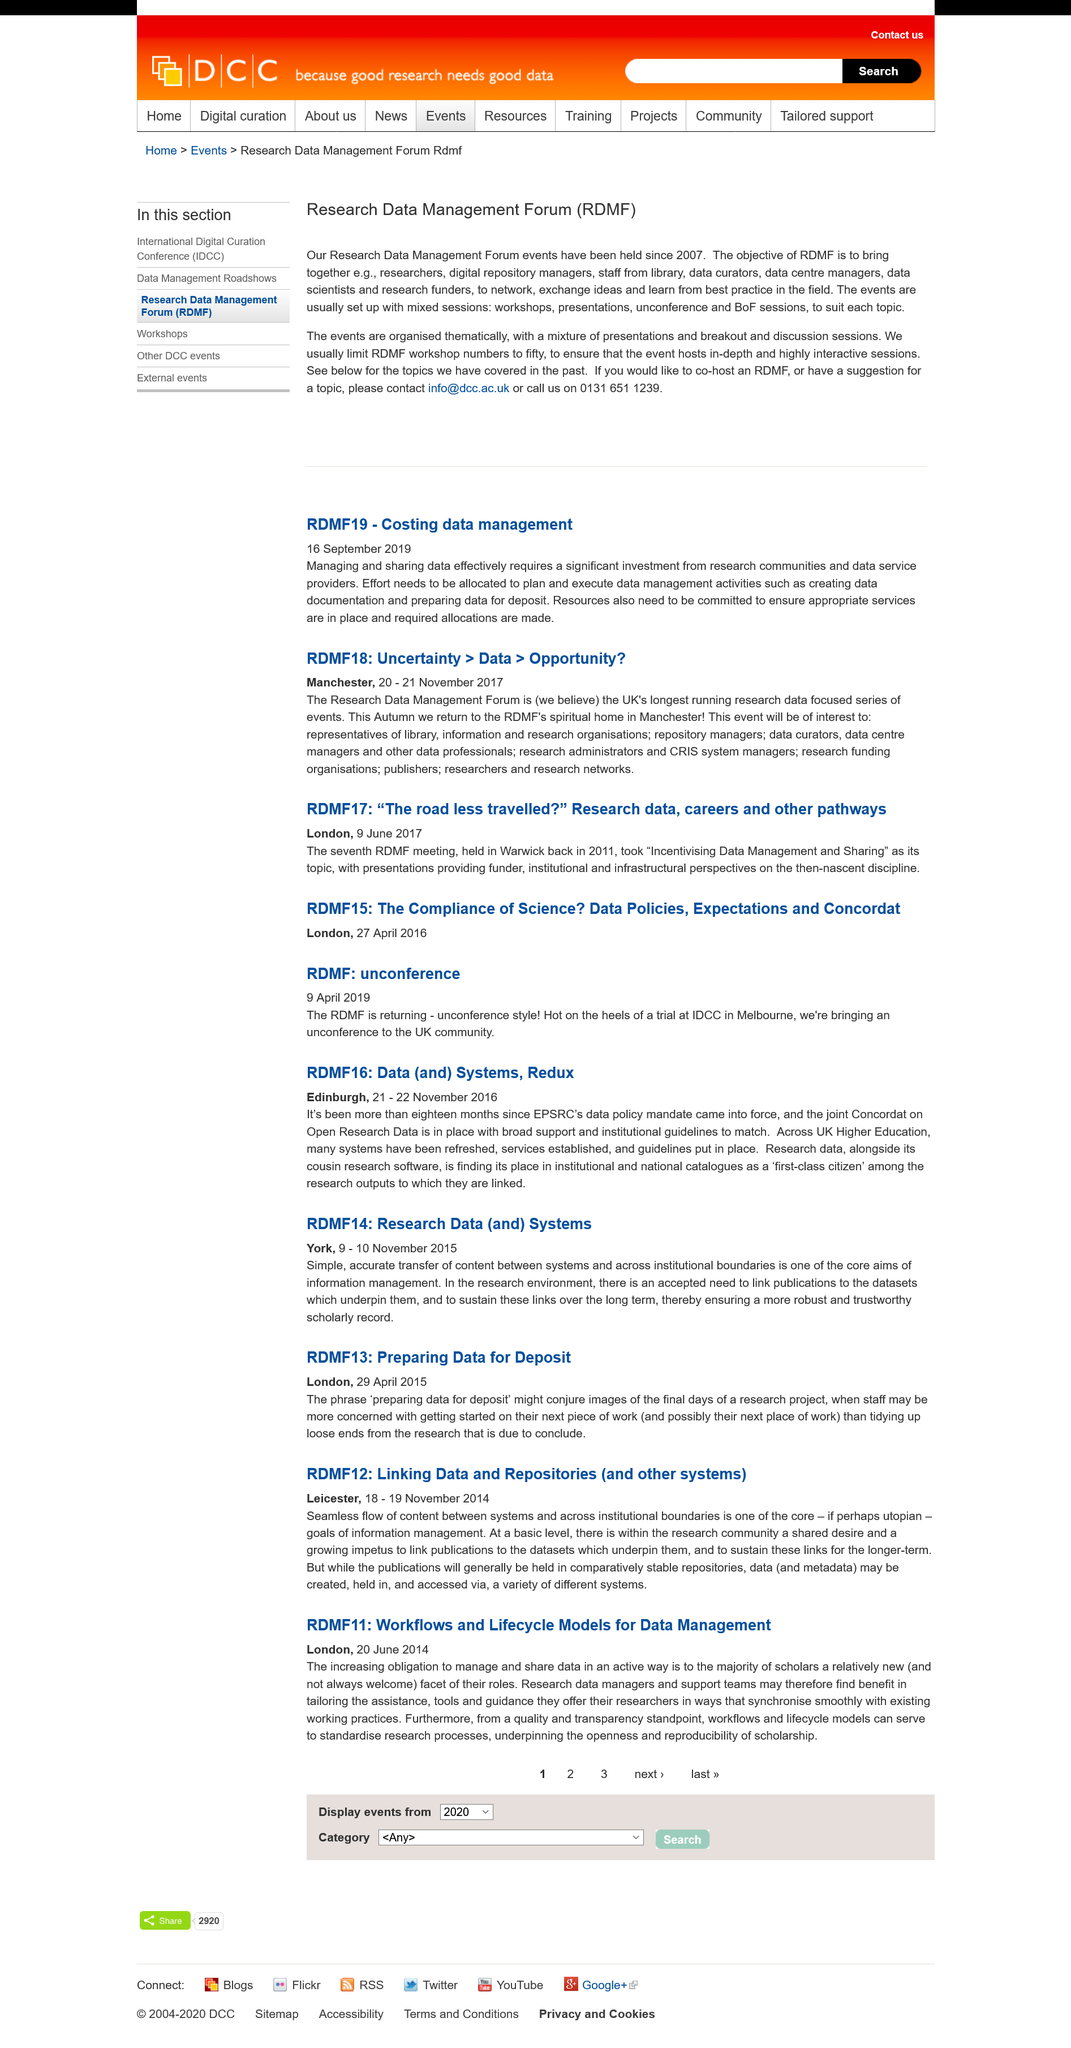Draw attention to some important aspects in this diagram. The second article was published in 2019, and the year in which it was published was 2019. RDMF14 was held from 9-10 November 2015. The contact email is [info@dcc.ac.uk](mailto:info@dcc.ac.uk). The first article was published in 2017. RDMF13 took place in London. 